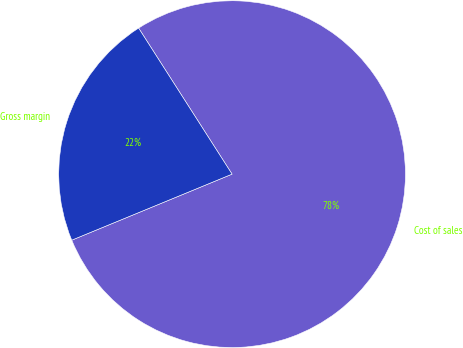Convert chart to OTSL. <chart><loc_0><loc_0><loc_500><loc_500><pie_chart><fcel>Cost of sales<fcel>Gross margin<nl><fcel>77.84%<fcel>22.16%<nl></chart> 